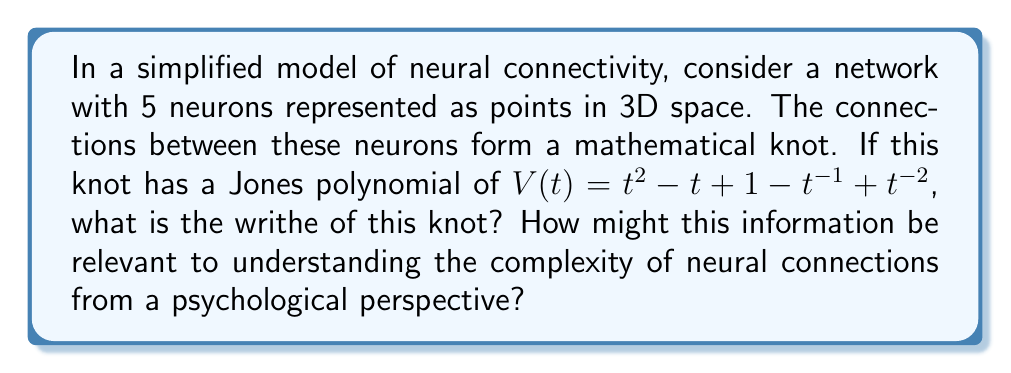Provide a solution to this math problem. Let's approach this step-by-step:

1) The Jones polynomial is a knot invariant that can provide information about the knot's structure. In this case, we're given:

   $V(t) = t^2 - t + 1 - t^{-1} + t^{-2}$

2) There's a relationship between the Jones polynomial and the writhe of a knot. Specifically, for an oriented link L, the following relation holds:

   $V_L(e^{h/4}) = (-1)^{w(L)-1}(e^{h/4} - e^{-h/4}) + O(h^2)$

   Where $w(L)$ is the writhe of the link L.

3) To use this relation, we need to expand $V(e^{h/4})$ and compare it with the given Jones polynomial:

   $V(e^{h/4}) = e^{h/2} - e^{h/4} + 1 - e^{-h/4} + e^{-h/2}$

4) Expanding this using Taylor series:

   $V(e^{h/4}) = (1 + \frac{h}{2} + ...) - (1 + \frac{h}{4} + ...) + 1 - (1 - \frac{h}{4} + ...) + (1 - \frac{h}{2} + ...)$
   
   $= -h + O(h^2)$

5) Comparing this with the relation in step 2:

   $-h = (-1)^{w(L)-1}(e^{h/4} - e^{-h/4}) + O(h^2)$
   
   $-h = (-1)^{w(L)-1}(h/2 + O(h^2))$

6) For this equality to hold, we must have:

   $(-1)^{w(L)-1} = -2$
   
   This is only true when $w(L) - 1$ is odd, or equivalently, when $w(L)$ is even.

7) The smallest even integer that satisfies this is 2.

From a psychological perspective, the writhe of a knot can be seen as a measure of the complexity of connections in the neural network. A higher writhe suggests more complex crossings, which could indicate more intricate information processing or memory storage mechanisms. This mathematical approach to neural connectivity could provide insights into how the brain organizes and processes information, potentially offering new avenues for understanding cognitive processes and psychological phenomena.
Answer: 2 